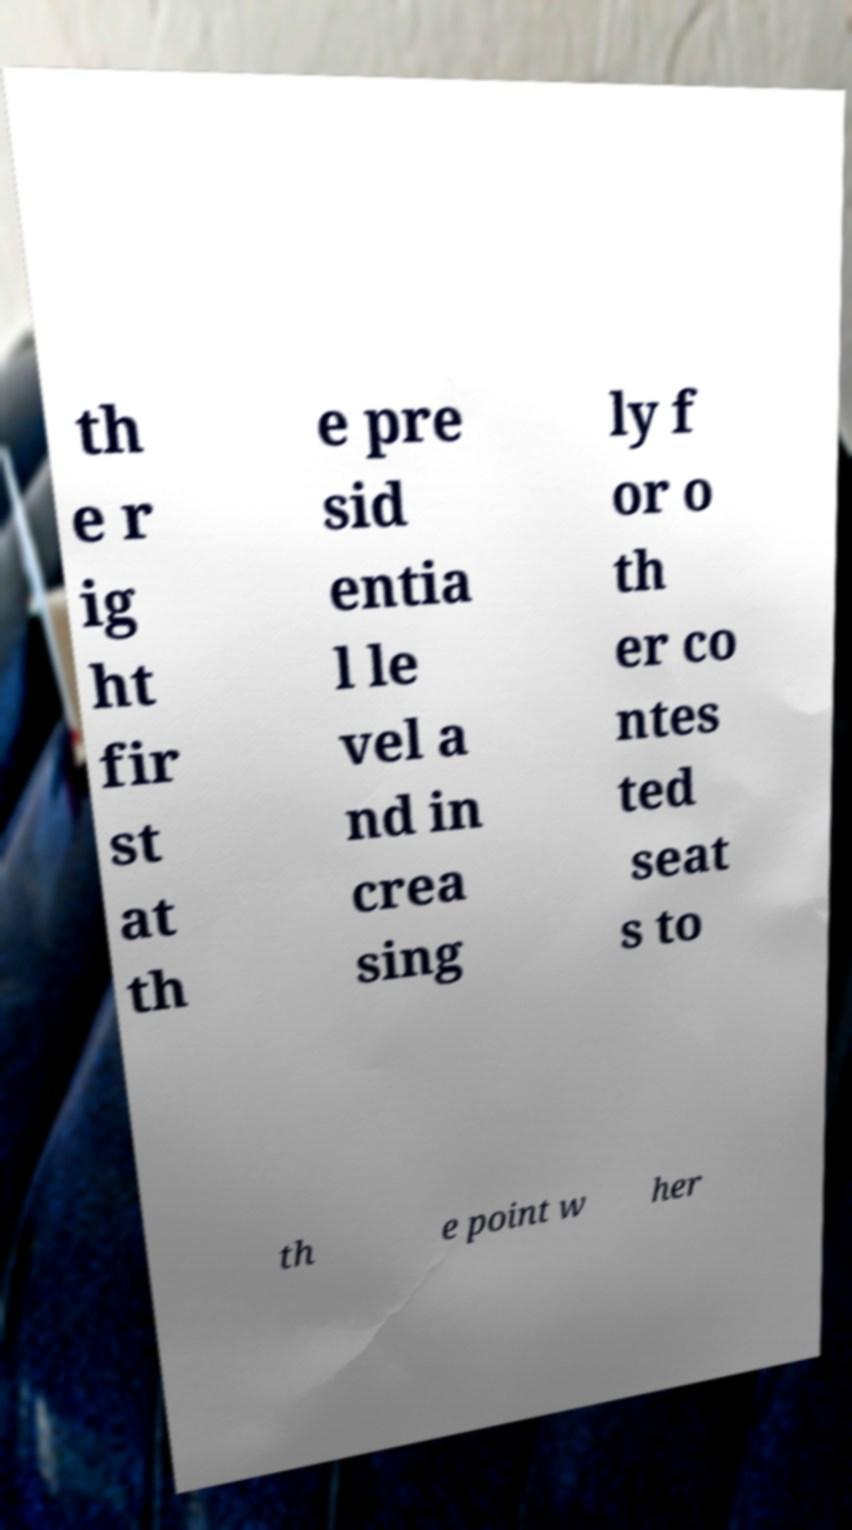Can you read and provide the text displayed in the image?This photo seems to have some interesting text. Can you extract and type it out for me? th e r ig ht fir st at th e pre sid entia l le vel a nd in crea sing ly f or o th er co ntes ted seat s to th e point w her 